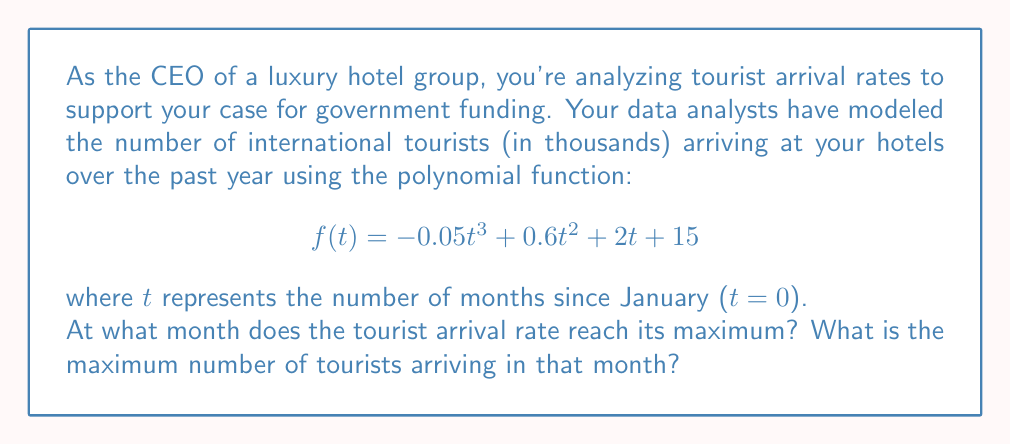Provide a solution to this math problem. To find the maximum of the function, we need to follow these steps:

1) Find the derivative of the function:
   $$f'(t) = -0.15t^2 + 1.2t + 2$$

2) Set the derivative equal to zero and solve for t:
   $$-0.15t^2 + 1.2t + 2 = 0$$

3) This is a quadratic equation. We can solve it using the quadratic formula:
   $$t = \frac{-b \pm \sqrt{b^2 - 4ac}}{2a}$$
   where $a = -0.15$, $b = 1.2$, and $c = 2$

4) Plugging in these values:
   $$t = \frac{-1.2 \pm \sqrt{1.44 - 4(-0.15)(2)}}{2(-0.15)}$$
   $$= \frac{-1.2 \pm \sqrt{1.44 + 1.2}}{-0.3}$$
   $$= \frac{-1.2 \pm \sqrt{2.64}}{-0.3}$$
   $$= \frac{-1.2 \pm 1.625}{-0.3}$$

5) This gives us two solutions:
   $$t_1 = \frac{-1.2 + 1.625}{-0.3} = -1.42$$
   $$t_2 = \frac{-1.2 - 1.625}{-0.3} = 9.42$$

6) Since time cannot be negative in this context, we take t = 9.42 months.

7) Rounding to the nearest month, the maximum occurs at t = 9 months (September).

8) To find the maximum number of tourists, we plug t = 9 into the original function:
   $$f(9) = -0.05(9^3) + 0.6(9^2) + 2(9) + 15$$
   $$= -36.45 + 48.6 + 18 + 15$$
   $$= 45.15$$

Therefore, the maximum number of tourists is approximately 45,150.
Answer: The tourist arrival rate reaches its maximum in September (9 months after January), with approximately 45,150 tourists arriving in that month. 